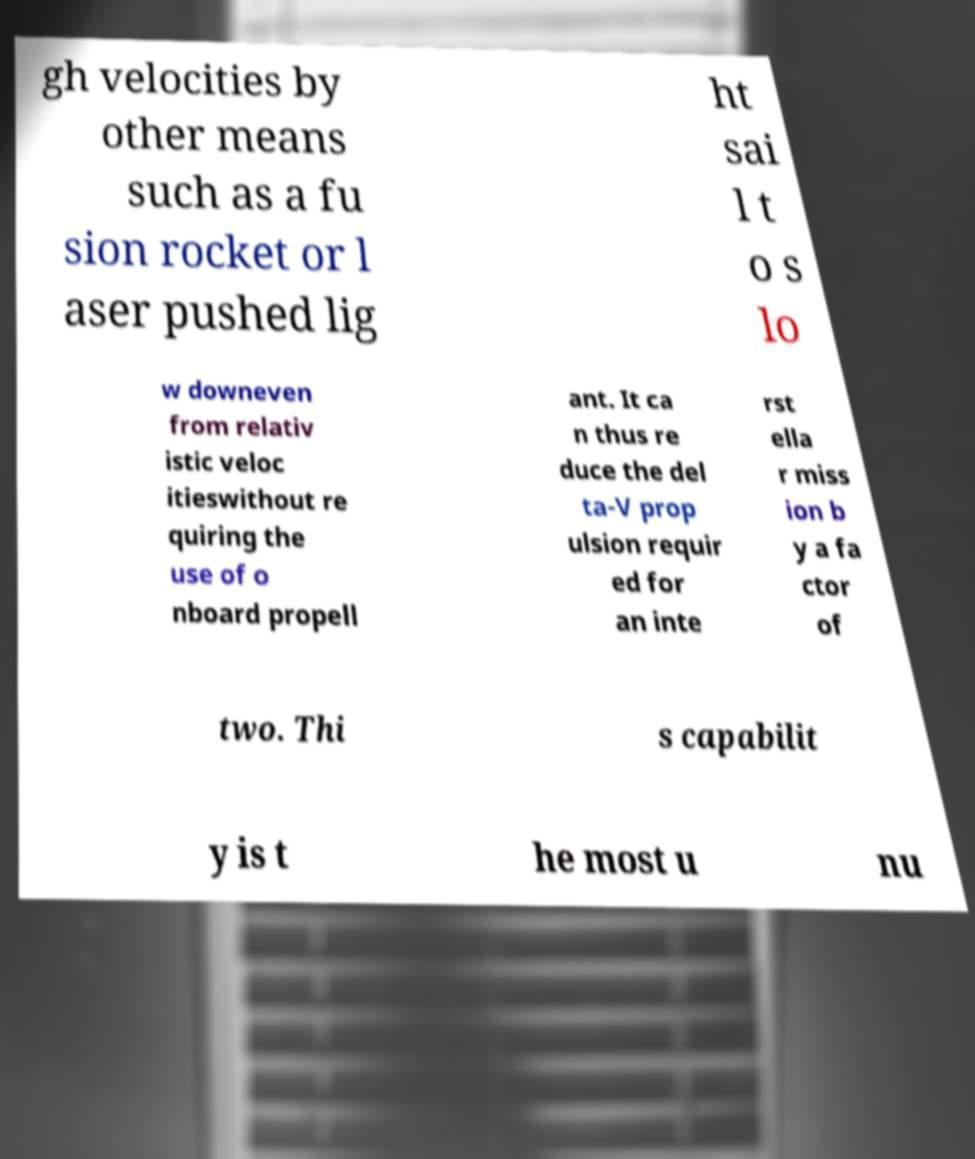Can you read and provide the text displayed in the image?This photo seems to have some interesting text. Can you extract and type it out for me? gh velocities by other means such as a fu sion rocket or l aser pushed lig ht sai l t o s lo w downeven from relativ istic veloc itieswithout re quiring the use of o nboard propell ant. It ca n thus re duce the del ta-V prop ulsion requir ed for an inte rst ella r miss ion b y a fa ctor of two. Thi s capabilit y is t he most u nu 